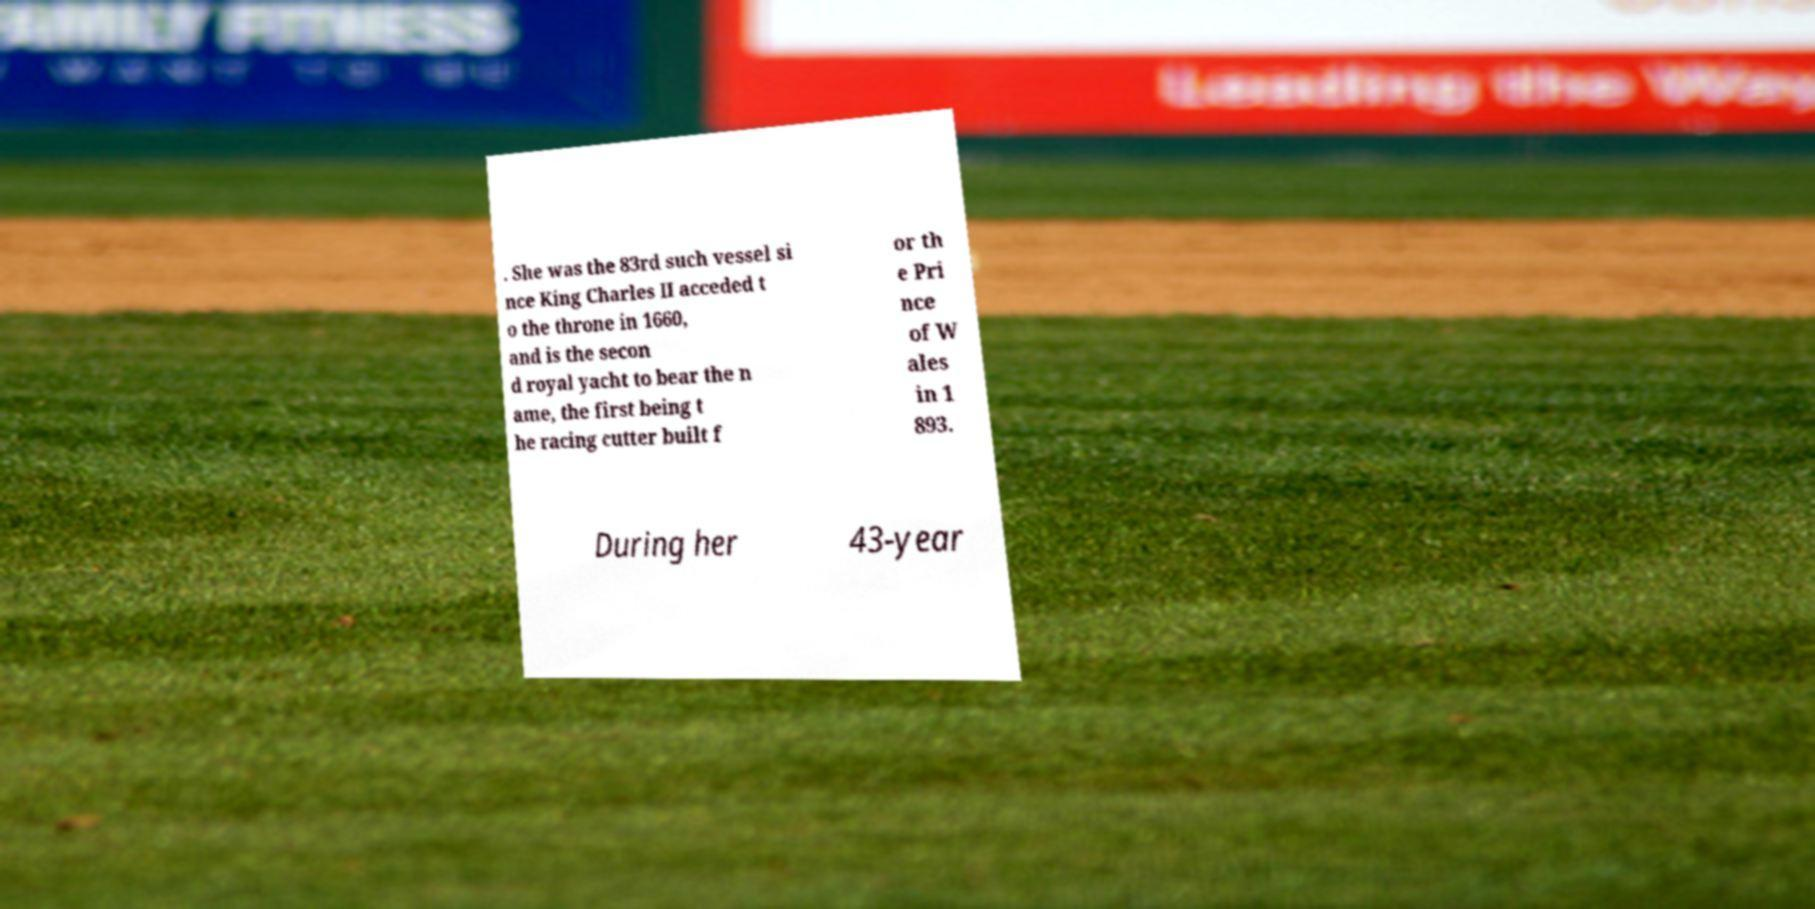Can you read and provide the text displayed in the image?This photo seems to have some interesting text. Can you extract and type it out for me? . She was the 83rd such vessel si nce King Charles II acceded t o the throne in 1660, and is the secon d royal yacht to bear the n ame, the first being t he racing cutter built f or th e Pri nce of W ales in 1 893. During her 43-year 